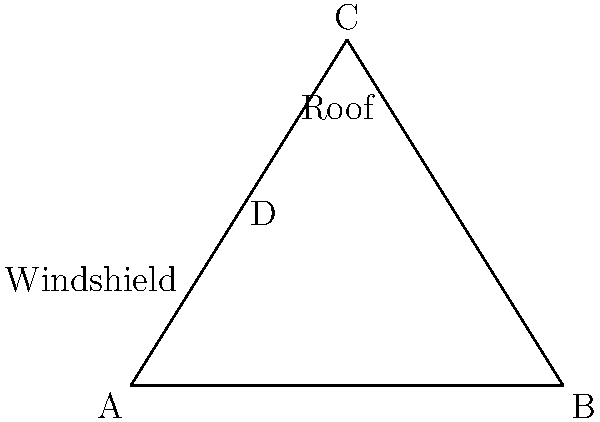In your Subaru, the windshield and roof form triangles as shown in the diagram. If triangle ACD is congruent to triangle BCD, what is the ratio of AD to DB? Let's approach this step-by-step:

1) Given that triangle ACD is congruent to triangle BCD, we know that:
   - AC = BC (side)
   - CD is common to both triangles
   - Angle ACD = Angle BCD (angle)

2) This means that point D is equidistant from A and B.

3) In other words, D is the midpoint of AB.

4) If D is the midpoint of AB, then:
   $AD = DB$

5) The ratio of two equal lengths is always 1:1.

Therefore, the ratio of AD to DB is 1:1.
Answer: 1:1 